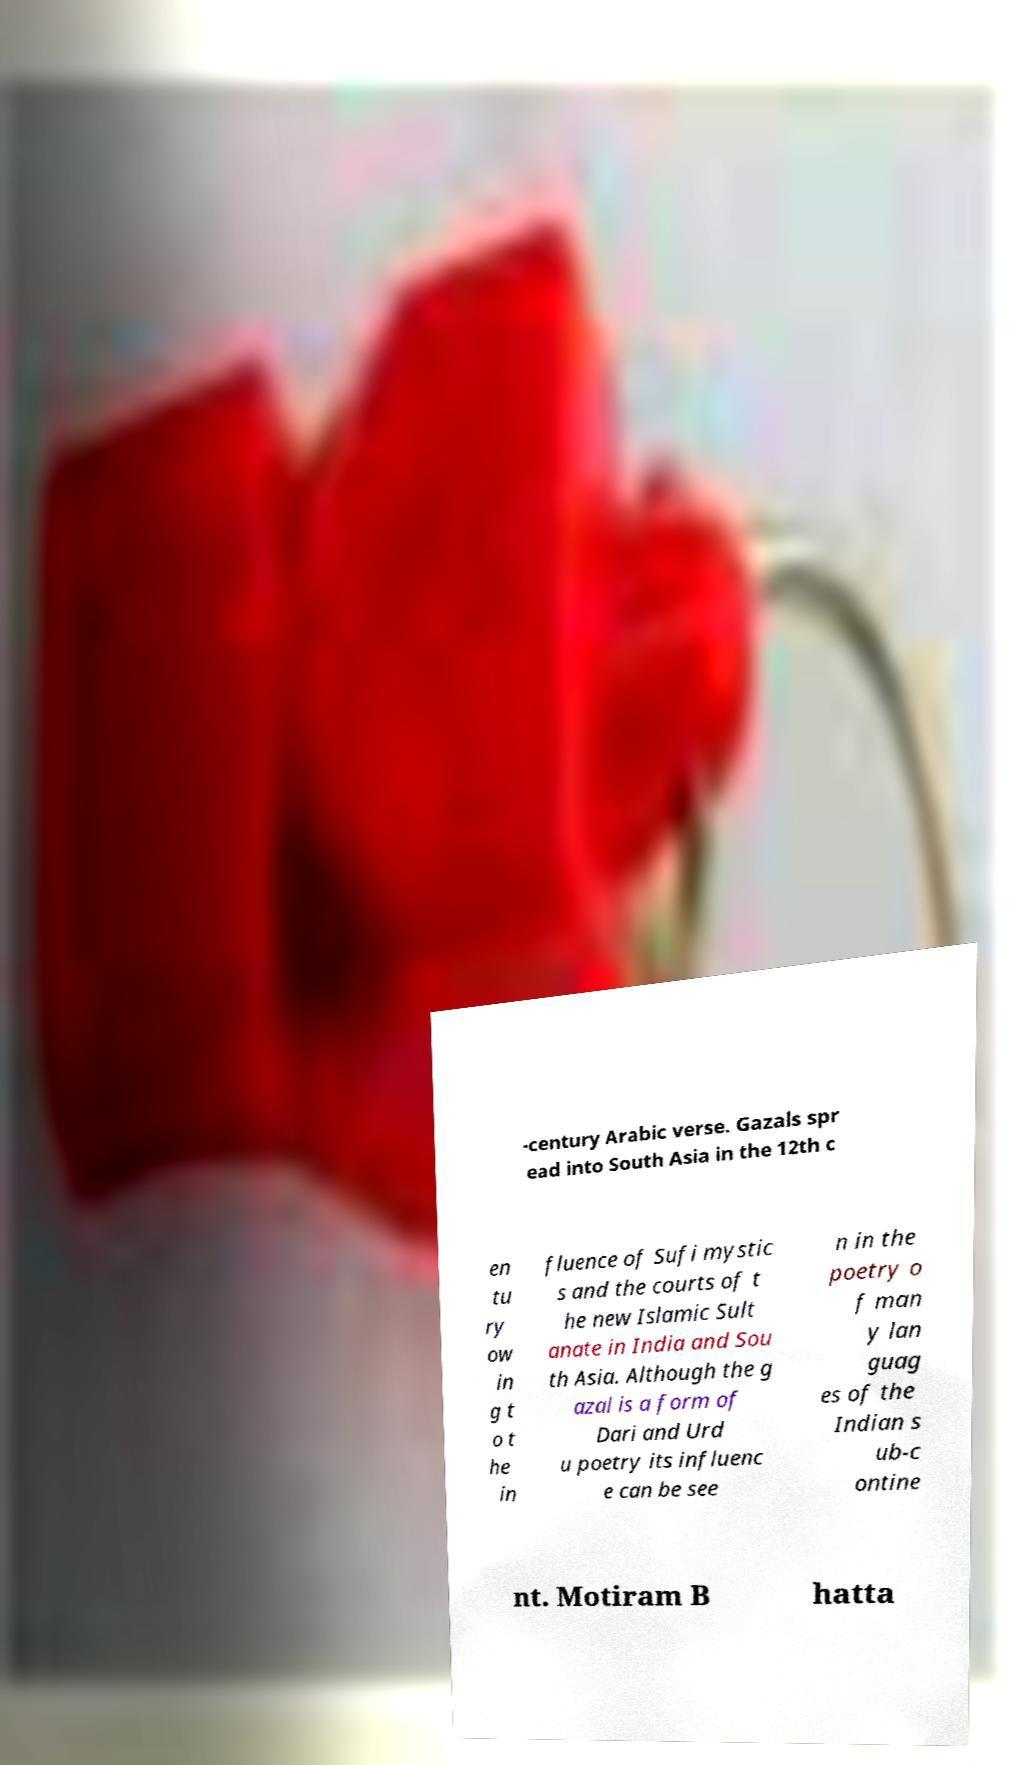Can you read and provide the text displayed in the image?This photo seems to have some interesting text. Can you extract and type it out for me? -century Arabic verse. Gazals spr ead into South Asia in the 12th c en tu ry ow in g t o t he in fluence of Sufi mystic s and the courts of t he new Islamic Sult anate in India and Sou th Asia. Although the g azal is a form of Dari and Urd u poetry its influenc e can be see n in the poetry o f man y lan guag es of the Indian s ub-c ontine nt. Motiram B hatta 